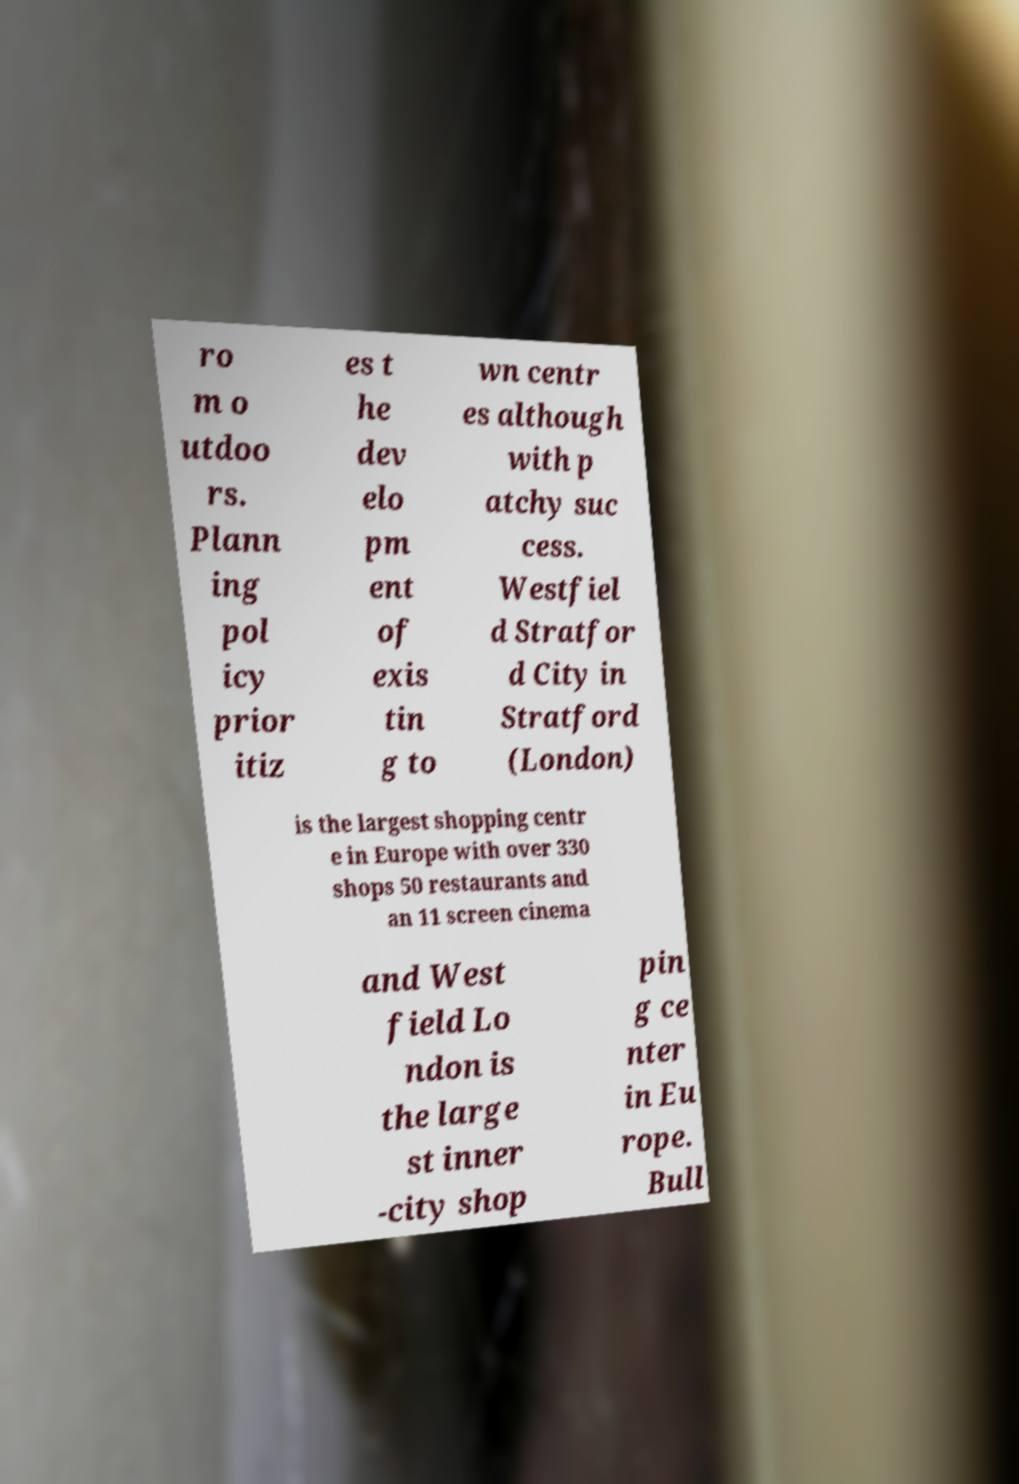There's text embedded in this image that I need extracted. Can you transcribe it verbatim? ro m o utdoo rs. Plann ing pol icy prior itiz es t he dev elo pm ent of exis tin g to wn centr es although with p atchy suc cess. Westfiel d Stratfor d City in Stratford (London) is the largest shopping centr e in Europe with over 330 shops 50 restaurants and an 11 screen cinema and West field Lo ndon is the large st inner -city shop pin g ce nter in Eu rope. Bull 